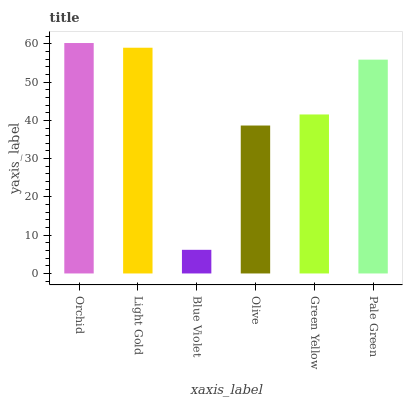Is Blue Violet the minimum?
Answer yes or no. Yes. Is Orchid the maximum?
Answer yes or no. Yes. Is Light Gold the minimum?
Answer yes or no. No. Is Light Gold the maximum?
Answer yes or no. No. Is Orchid greater than Light Gold?
Answer yes or no. Yes. Is Light Gold less than Orchid?
Answer yes or no. Yes. Is Light Gold greater than Orchid?
Answer yes or no. No. Is Orchid less than Light Gold?
Answer yes or no. No. Is Pale Green the high median?
Answer yes or no. Yes. Is Green Yellow the low median?
Answer yes or no. Yes. Is Blue Violet the high median?
Answer yes or no. No. Is Blue Violet the low median?
Answer yes or no. No. 